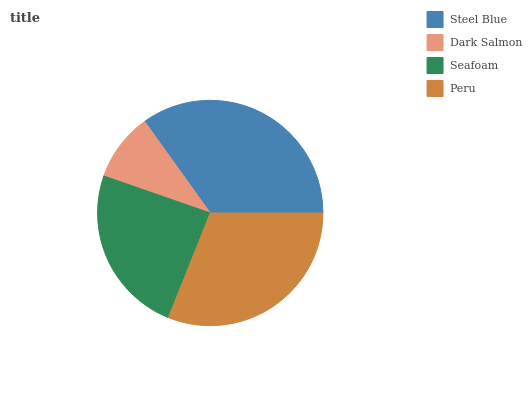Is Dark Salmon the minimum?
Answer yes or no. Yes. Is Steel Blue the maximum?
Answer yes or no. Yes. Is Seafoam the minimum?
Answer yes or no. No. Is Seafoam the maximum?
Answer yes or no. No. Is Seafoam greater than Dark Salmon?
Answer yes or no. Yes. Is Dark Salmon less than Seafoam?
Answer yes or no. Yes. Is Dark Salmon greater than Seafoam?
Answer yes or no. No. Is Seafoam less than Dark Salmon?
Answer yes or no. No. Is Peru the high median?
Answer yes or no. Yes. Is Seafoam the low median?
Answer yes or no. Yes. Is Steel Blue the high median?
Answer yes or no. No. Is Dark Salmon the low median?
Answer yes or no. No. 